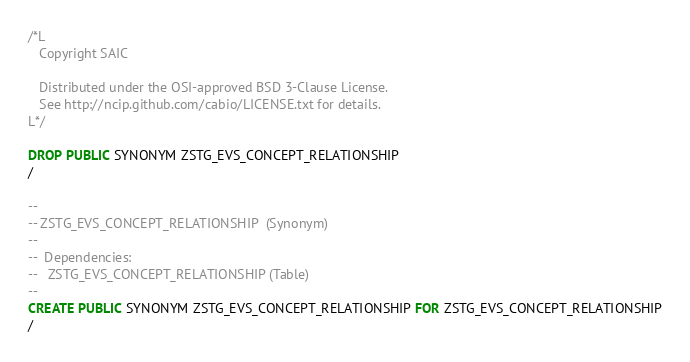<code> <loc_0><loc_0><loc_500><loc_500><_SQL_>/*L
   Copyright SAIC

   Distributed under the OSI-approved BSD 3-Clause License.
   See http://ncip.github.com/cabio/LICENSE.txt for details.
L*/

DROP PUBLIC SYNONYM ZSTG_EVS_CONCEPT_RELATIONSHIP
/

--
-- ZSTG_EVS_CONCEPT_RELATIONSHIP  (Synonym) 
--
--  Dependencies: 
--   ZSTG_EVS_CONCEPT_RELATIONSHIP (Table)
--
CREATE PUBLIC SYNONYM ZSTG_EVS_CONCEPT_RELATIONSHIP FOR ZSTG_EVS_CONCEPT_RELATIONSHIP
/


</code> 